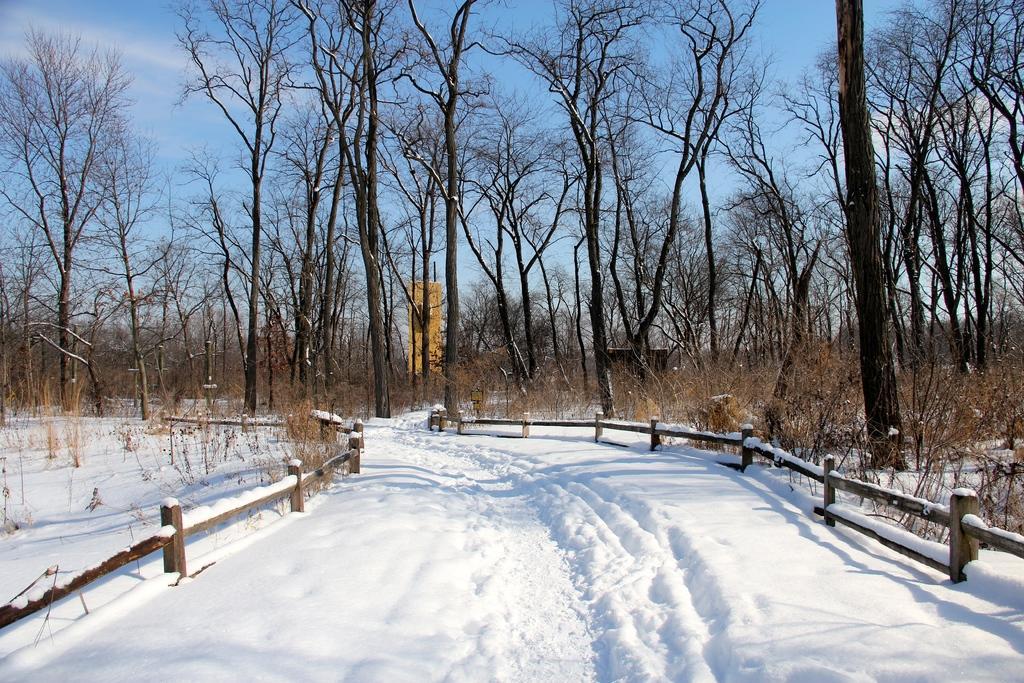Please provide a concise description of this image. In this image we can see snow, wooden fence, trees and sky in the background. 